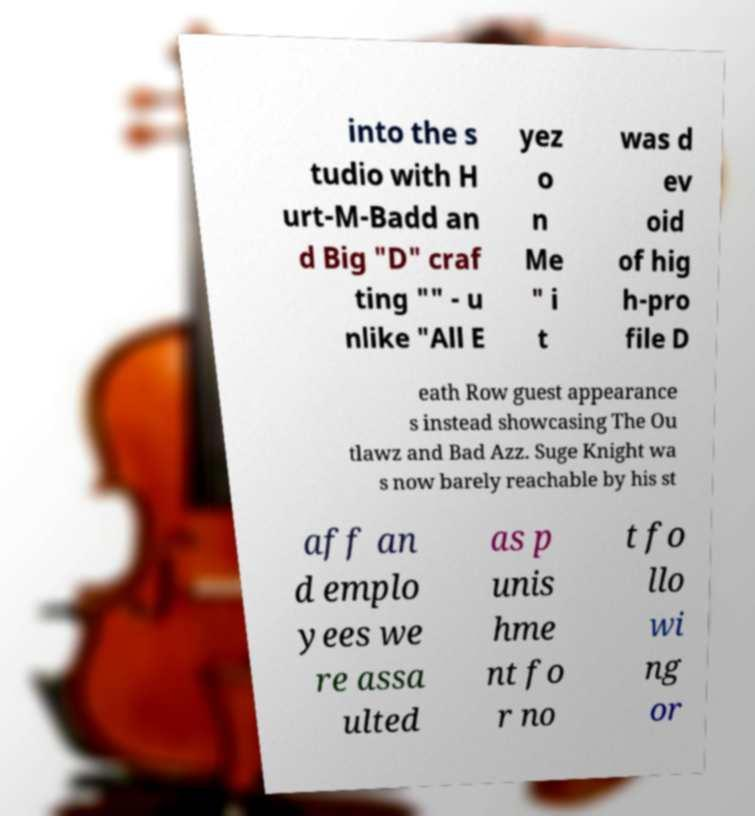Could you assist in decoding the text presented in this image and type it out clearly? into the s tudio with H urt-M-Badd an d Big "D" craf ting "" - u nlike "All E yez o n Me " i t was d ev oid of hig h-pro file D eath Row guest appearance s instead showcasing The Ou tlawz and Bad Azz. Suge Knight wa s now barely reachable by his st aff an d emplo yees we re assa ulted as p unis hme nt fo r no t fo llo wi ng or 